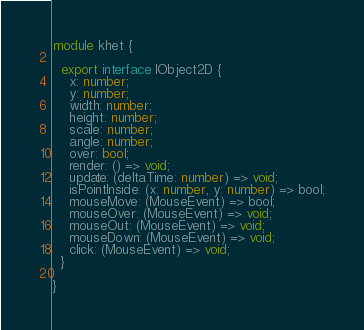Convert code to text. <code><loc_0><loc_0><loc_500><loc_500><_TypeScript_>module khet {

  export interface IObject2D {
    x: number;
    y: number;
    width: number;
    height: number;
    scale: number;
    angle: number;
    over: bool;
    render: () => void;
    update: (deltaTime: number) => void;
    isPointInside: (x: number, y: number) => bool;
    mouseMove: (MouseEvent) => bool;
    mouseOver: (MouseEvent) => void;
    mouseOut: (MouseEvent) => void;
    mouseDown: (MouseEvent) => void;
    click: (MouseEvent) => void;
  }

}
</code> 